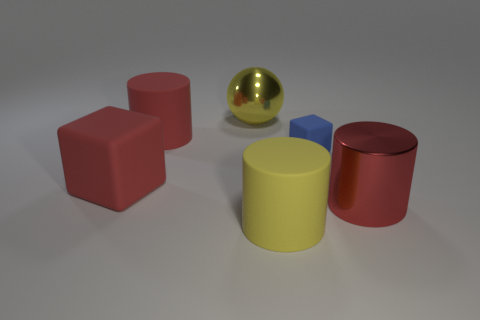Add 2 large yellow balls. How many objects exist? 8 Subtract all cubes. How many objects are left? 4 Subtract all big things. Subtract all large red matte cylinders. How many objects are left? 0 Add 3 large metal spheres. How many large metal spheres are left? 4 Add 4 big brown rubber cubes. How many big brown rubber cubes exist? 4 Subtract 0 brown blocks. How many objects are left? 6 